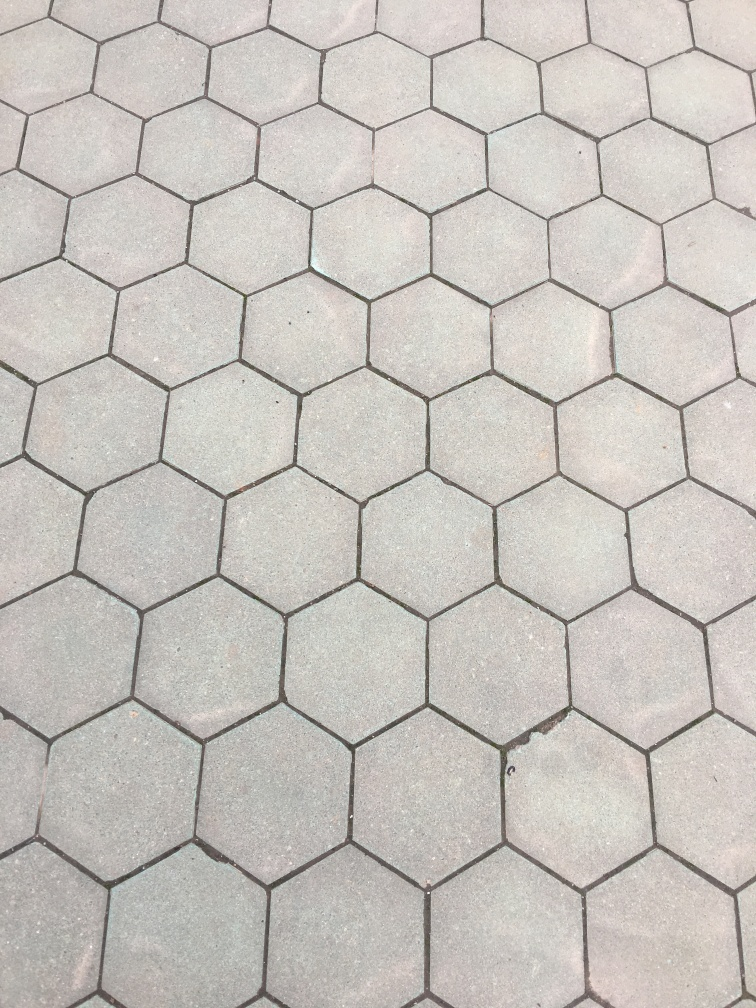How would you rate the quality of this image?
A. Moderate.
B. Excellent
C. Poor
Answer with the option's letter from the given choices directly.
 A. 